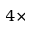Convert formula to latex. <formula><loc_0><loc_0><loc_500><loc_500>4 \times</formula> 